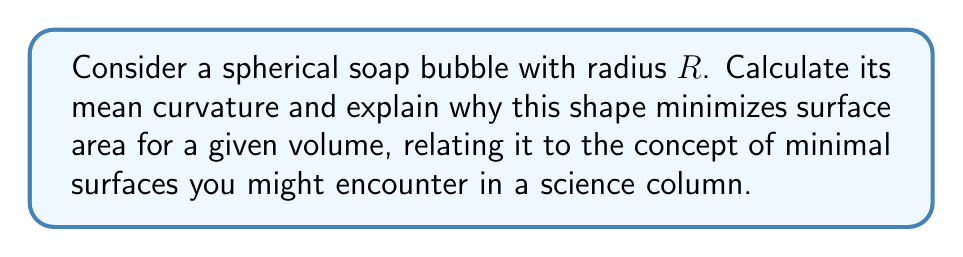Show me your answer to this math problem. Let's approach this step-by-step:

1) The mean curvature $H$ of a surface is defined as the average of the principal curvatures:

   $$ H = \frac{1}{2}(\kappa_1 + \kappa_2) $$

   where $\kappa_1$ and $\kappa_2$ are the principal curvatures.

2) For a sphere, the principal curvatures are equal and constant at every point:

   $$ \kappa_1 = \kappa_2 = \frac{1}{R} $$

3) Substituting into the mean curvature formula:

   $$ H = \frac{1}{2}(\frac{1}{R} + \frac{1}{R}) = \frac{1}{R} $$

4) The shape of a soap bubble is determined by surface tension, which acts to minimize the surface area for a given volume. This is related to the concept of minimal surfaces.

5) The relationship between mean curvature and surface minimization is given by the Young-Laplace equation:

   $$ \Delta p = 2\gamma H $$

   where $\Delta p$ is the pressure difference across the surface and $\gamma$ is the surface tension.

6) For a soap bubble, $\Delta p$ is constant everywhere on the surface. Given that $H = \frac{1}{R}$, this equation is satisfied only for a sphere, as it's the only shape with constant mean curvature that encloses a volume.

7) This explains why soap bubbles are spherical: it's the shape that minimizes surface area for a given volume while maintaining a constant pressure difference.
Answer: $H = \frac{1}{R}$; sphere minimizes surface area for given volume. 